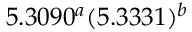Convert formula to latex. <formula><loc_0><loc_0><loc_500><loc_500>5 . 3 0 9 0 ^ { a } ( 5 . 3 3 3 1 ) ^ { b }</formula> 